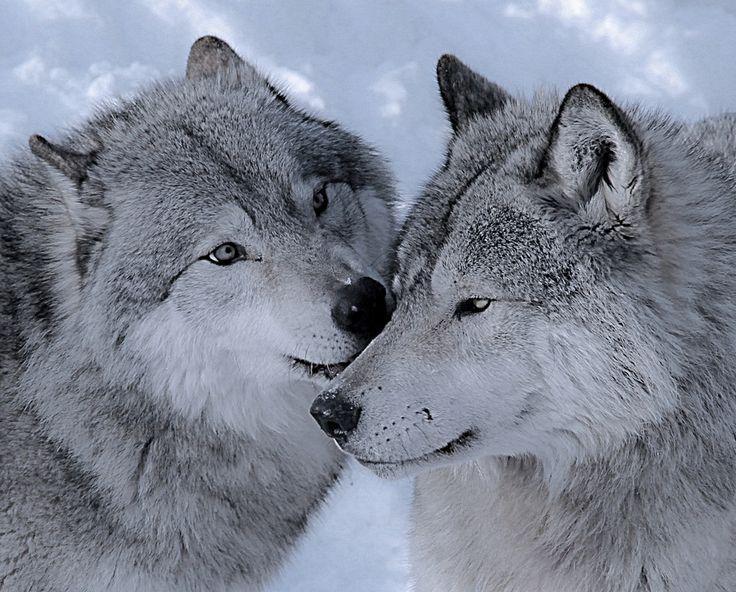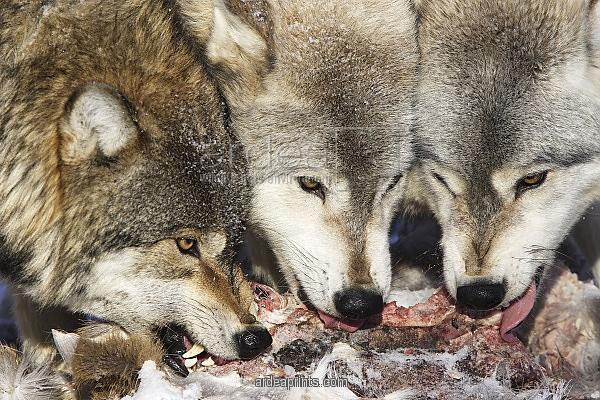The first image is the image on the left, the second image is the image on the right. Given the left and right images, does the statement "One image shows a single wolf carrying something in its mouth." hold true? Answer yes or no. No. The first image is the image on the left, the second image is the image on the right. Evaluate the accuracy of this statement regarding the images: "There are exactly three wolves out doors.". Is it true? Answer yes or no. No. 